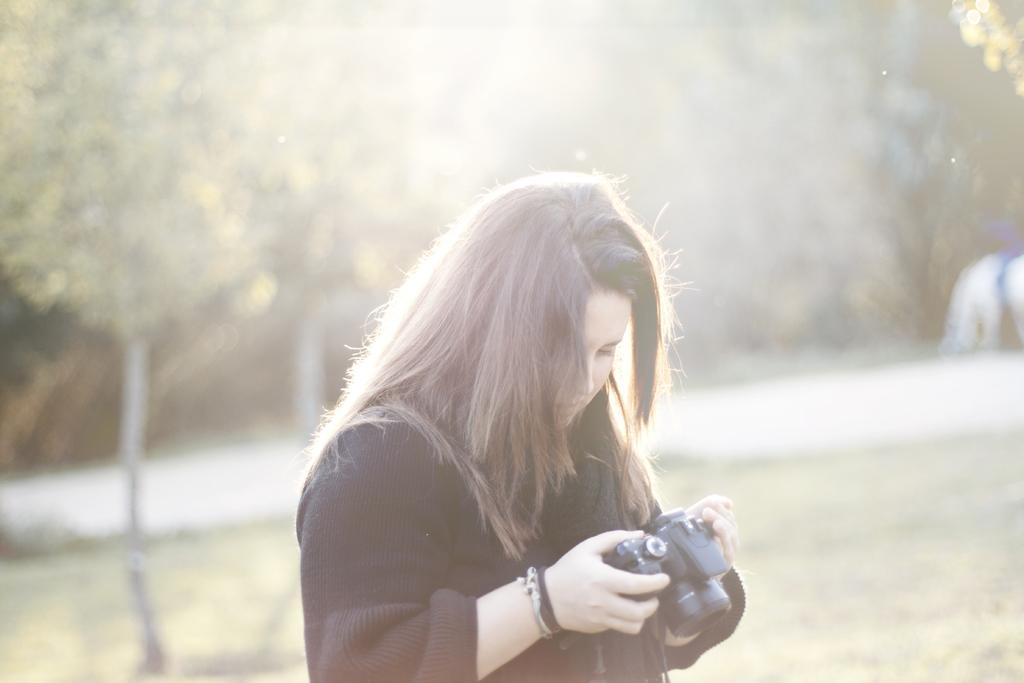What type of vegetation is present in the image? There are many trees in the image. What is the person in the image doing? The person is holding a camera in the image. What is the terrain like in the image? There is a grassy land in the image. What type of rail can be seen in the image? There is no rail present in the image. What kind of bone is visible in the image? There are no bones present in the image. 